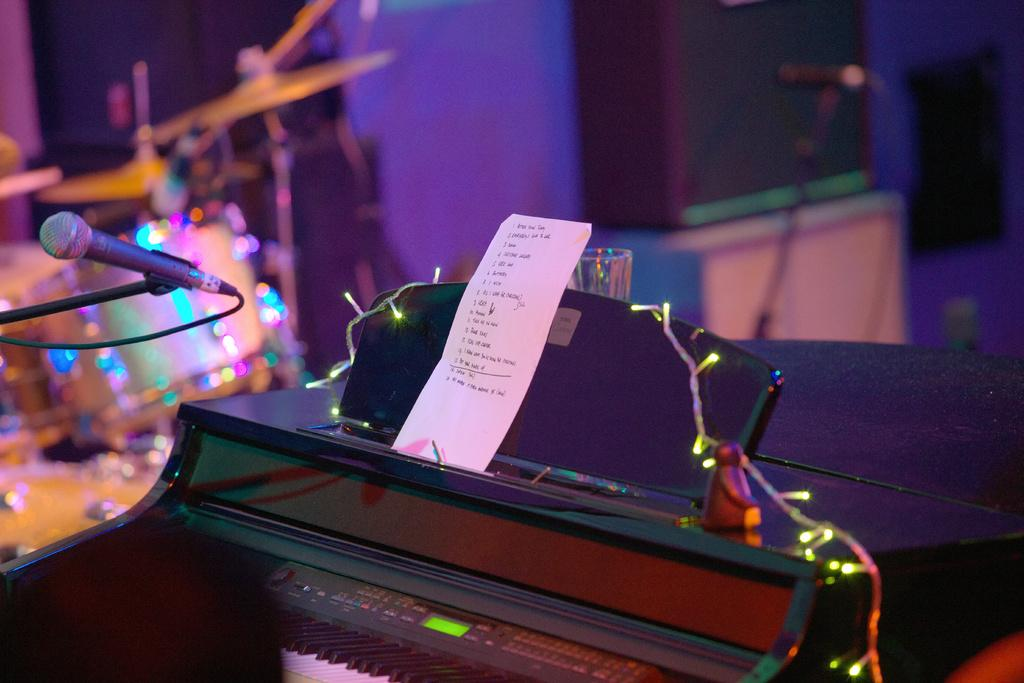What musical instrument is the main focus of the image? There is a piano in the image. What is placed on top of the piano? There is a paper on the piano. What is positioned above the piano? There is a microphone above the piano. What feature of the microphone is mentioned in the facts? The microphone has lights on it. What other musical instrument can be seen in the background of the image? There is a drum kit in the background of the image. What type of health care is being provided to the piano in the image? There is no indication of any health care being provided to the piano in the image. What is the emotional state of the heart in the image? There is no heart present in the image, so it is not possible to determine its emotional state. 